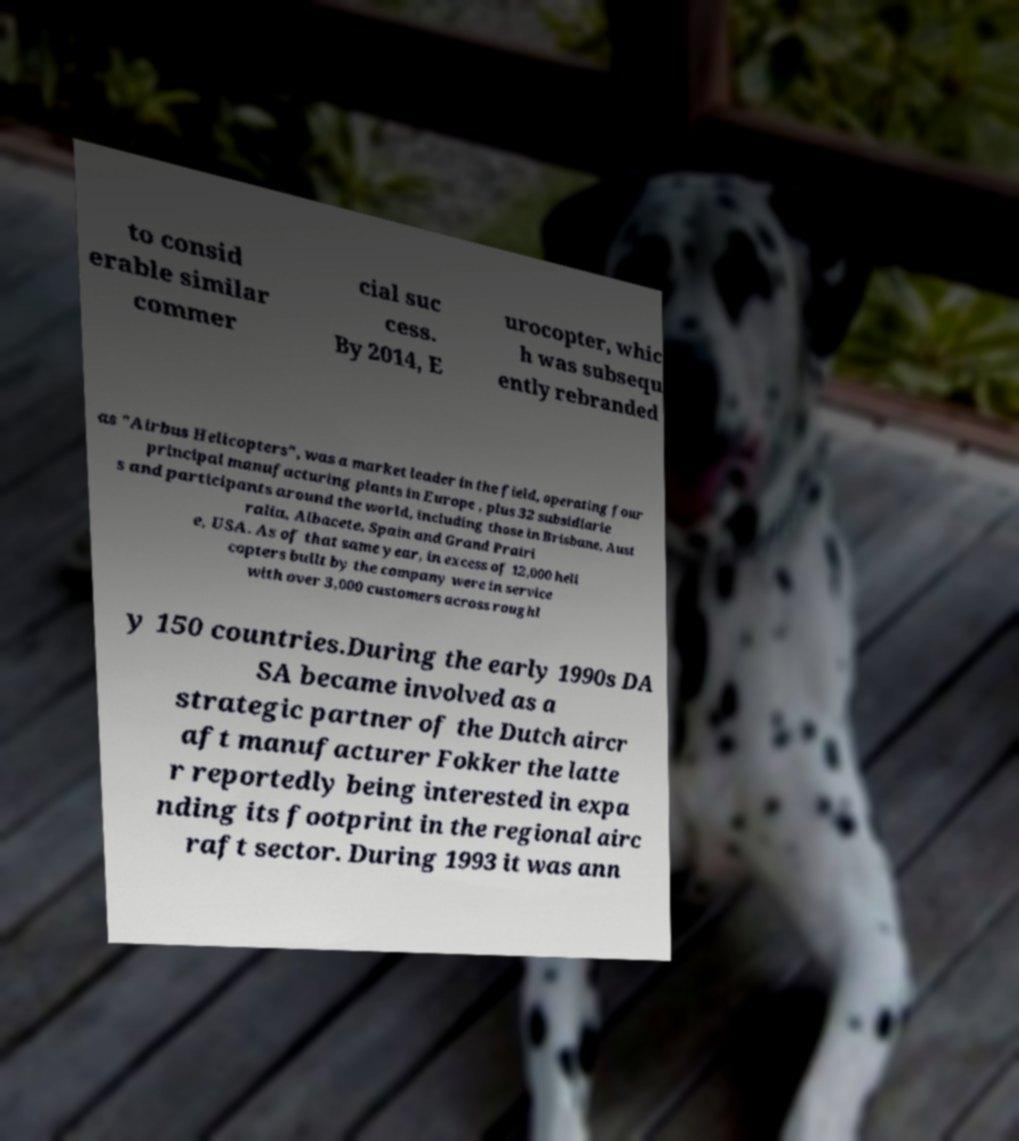Please read and relay the text visible in this image. What does it say? to consid erable similar commer cial suc cess. By 2014, E urocopter, whic h was subsequ ently rebranded as "Airbus Helicopters", was a market leader in the field, operating four principal manufacturing plants in Europe , plus 32 subsidiarie s and participants around the world, including those in Brisbane, Aust ralia, Albacete, Spain and Grand Prairi e, USA. As of that same year, in excess of 12,000 heli copters built by the company were in service with over 3,000 customers across roughl y 150 countries.During the early 1990s DA SA became involved as a strategic partner of the Dutch aircr aft manufacturer Fokker the latte r reportedly being interested in expa nding its footprint in the regional airc raft sector. During 1993 it was ann 